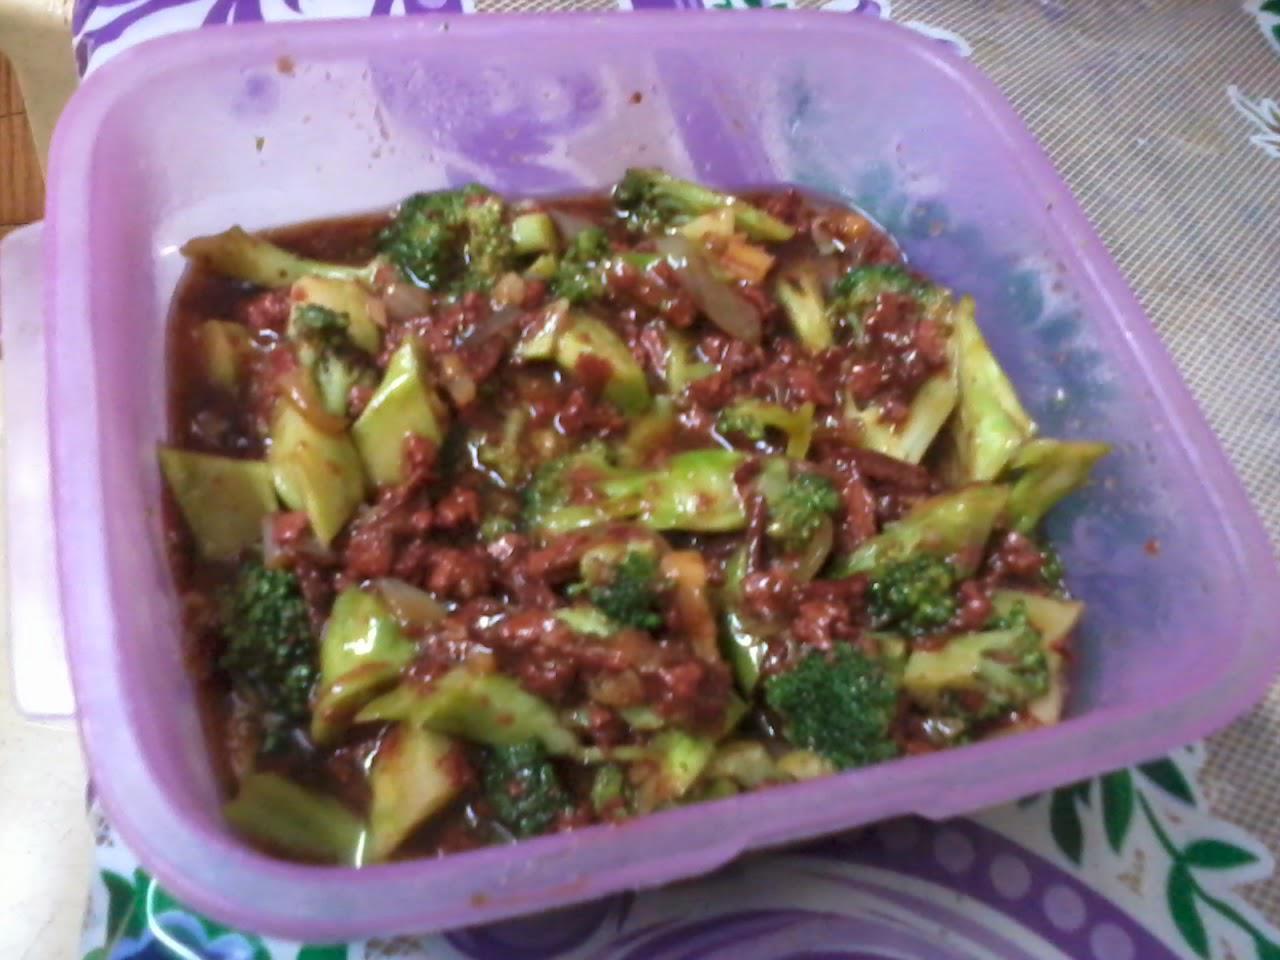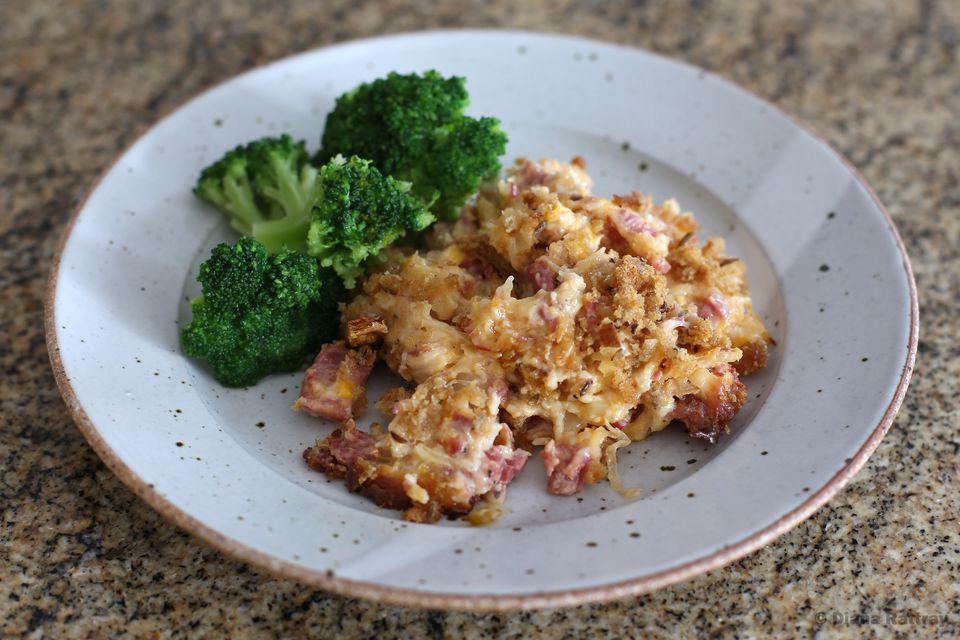The first image is the image on the left, the second image is the image on the right. Considering the images on both sides, is "Broccoli stir fry is being served in the center of two white plates." valid? Answer yes or no. No. The first image is the image on the left, the second image is the image on the right. Given the left and right images, does the statement "The left and right image contains the same number of white plates with broccoli and beef." hold true? Answer yes or no. No. 